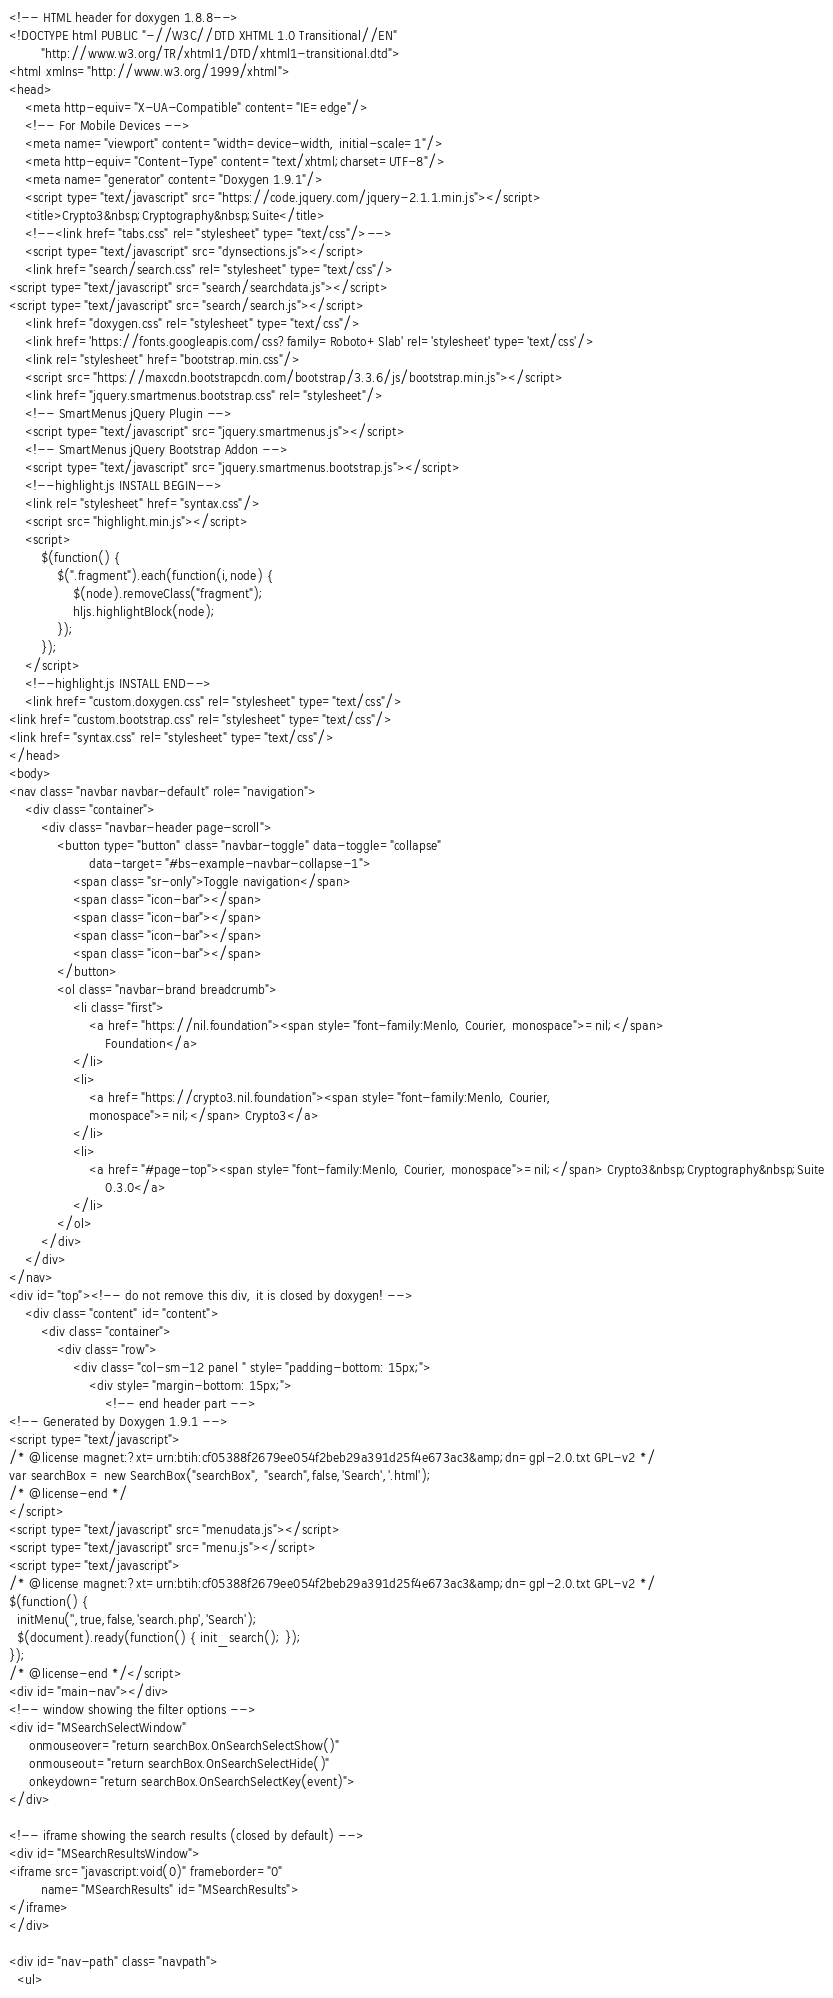Convert code to text. <code><loc_0><loc_0><loc_500><loc_500><_HTML_><!-- HTML header for doxygen 1.8.8-->
<!DOCTYPE html PUBLIC "-//W3C//DTD XHTML 1.0 Transitional//EN"
        "http://www.w3.org/TR/xhtml1/DTD/xhtml1-transitional.dtd">
<html xmlns="http://www.w3.org/1999/xhtml">
<head>
    <meta http-equiv="X-UA-Compatible" content="IE=edge"/>
    <!-- For Mobile Devices -->
    <meta name="viewport" content="width=device-width, initial-scale=1"/>
    <meta http-equiv="Content-Type" content="text/xhtml;charset=UTF-8"/>
    <meta name="generator" content="Doxygen 1.9.1"/>
    <script type="text/javascript" src="https://code.jquery.com/jquery-2.1.1.min.js"></script>
    <title>Crypto3&nbsp;Cryptography&nbsp;Suite</title>
    <!--<link href="tabs.css" rel="stylesheet" type="text/css"/>-->
    <script type="text/javascript" src="dynsections.js"></script>
    <link href="search/search.css" rel="stylesheet" type="text/css"/>
<script type="text/javascript" src="search/searchdata.js"></script>
<script type="text/javascript" src="search/search.js"></script>
    <link href="doxygen.css" rel="stylesheet" type="text/css"/>
    <link href='https://fonts.googleapis.com/css?family=Roboto+Slab' rel='stylesheet' type='text/css'/>
    <link rel="stylesheet" href="bootstrap.min.css"/>
    <script src="https://maxcdn.bootstrapcdn.com/bootstrap/3.3.6/js/bootstrap.min.js"></script>
    <link href="jquery.smartmenus.bootstrap.css" rel="stylesheet"/>
    <!-- SmartMenus jQuery Plugin -->
    <script type="text/javascript" src="jquery.smartmenus.js"></script>
    <!-- SmartMenus jQuery Bootstrap Addon -->
    <script type="text/javascript" src="jquery.smartmenus.bootstrap.js"></script>
    <!--highlight.js INSTALL BEGIN-->
    <link rel="stylesheet" href="syntax.css"/>
    <script src="highlight.min.js"></script>
    <script>
        $(function() {
            $(".fragment").each(function(i,node) {
                $(node).removeClass("fragment");
                hljs.highlightBlock(node);
            });
        });
    </script>
    <!--highlight.js INSTALL END-->
    <link href="custom.doxygen.css" rel="stylesheet" type="text/css"/>
<link href="custom.bootstrap.css" rel="stylesheet" type="text/css"/>
<link href="syntax.css" rel="stylesheet" type="text/css"/>
</head>
<body>
<nav class="navbar navbar-default" role="navigation">
    <div class="container">
        <div class="navbar-header page-scroll">
            <button type="button" class="navbar-toggle" data-toggle="collapse"
                    data-target="#bs-example-navbar-collapse-1">
                <span class="sr-only">Toggle navigation</span>
                <span class="icon-bar"></span>
                <span class="icon-bar"></span>
                <span class="icon-bar"></span>
                <span class="icon-bar"></span>
            </button>
            <ol class="navbar-brand breadcrumb">
                <li class="first">
                    <a href="https://nil.foundation"><span style="font-family:Menlo, Courier, monospace">=nil;</span>
                        Foundation</a>
                </li>
                <li>
                    <a href="https://crypto3.nil.foundation"><span style="font-family:Menlo, Courier,
                    monospace">=nil;</span> Crypto3</a>
                </li>
                <li>
                    <a href="#page-top"><span style="font-family:Menlo, Courier, monospace">=nil;</span> Crypto3&nbsp;Cryptography&nbsp;Suite
                        0.3.0</a>
                </li>
            </ol>
        </div>
    </div>
</nav>
<div id="top"><!-- do not remove this div, it is closed by doxygen! -->
    <div class="content" id="content">
        <div class="container">
            <div class="row">
                <div class="col-sm-12 panel " style="padding-bottom: 15px;">
                    <div style="margin-bottom: 15px;">
                        <!-- end header part -->
<!-- Generated by Doxygen 1.9.1 -->
<script type="text/javascript">
/* @license magnet:?xt=urn:btih:cf05388f2679ee054f2beb29a391d25f4e673ac3&amp;dn=gpl-2.0.txt GPL-v2 */
var searchBox = new SearchBox("searchBox", "search",false,'Search','.html');
/* @license-end */
</script>
<script type="text/javascript" src="menudata.js"></script>
<script type="text/javascript" src="menu.js"></script>
<script type="text/javascript">
/* @license magnet:?xt=urn:btih:cf05388f2679ee054f2beb29a391d25f4e673ac3&amp;dn=gpl-2.0.txt GPL-v2 */
$(function() {
  initMenu('',true,false,'search.php','Search');
  $(document).ready(function() { init_search(); });
});
/* @license-end */</script>
<div id="main-nav"></div>
<!-- window showing the filter options -->
<div id="MSearchSelectWindow"
     onmouseover="return searchBox.OnSearchSelectShow()"
     onmouseout="return searchBox.OnSearchSelectHide()"
     onkeydown="return searchBox.OnSearchSelectKey(event)">
</div>

<!-- iframe showing the search results (closed by default) -->
<div id="MSearchResultsWindow">
<iframe src="javascript:void(0)" frameborder="0" 
        name="MSearchResults" id="MSearchResults">
</iframe>
</div>

<div id="nav-path" class="navpath">
  <ul></code> 